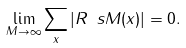Convert formula to latex. <formula><loc_0><loc_0><loc_500><loc_500>\lim _ { M \to \infty } \sum _ { x } | R _ { \ } s M ( x ) | = 0 .</formula> 